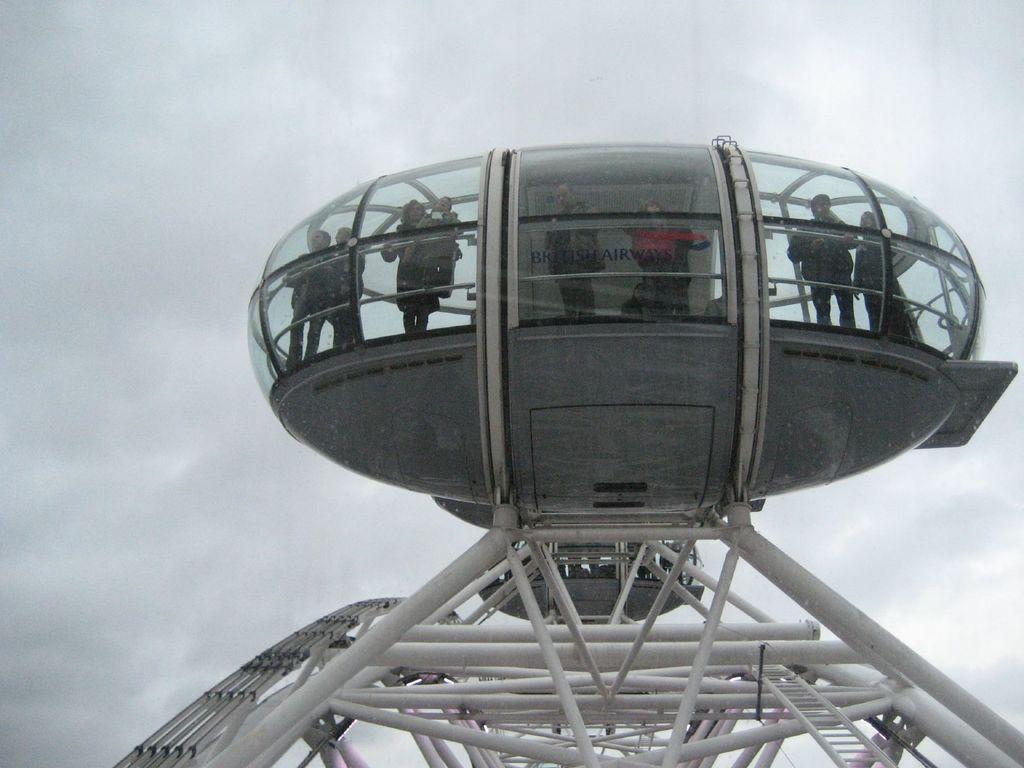Please provide a concise description of this image. In this image I can see a device which is looking like a space machine. Inside this few people are standing. In the background, I can see the sky. 